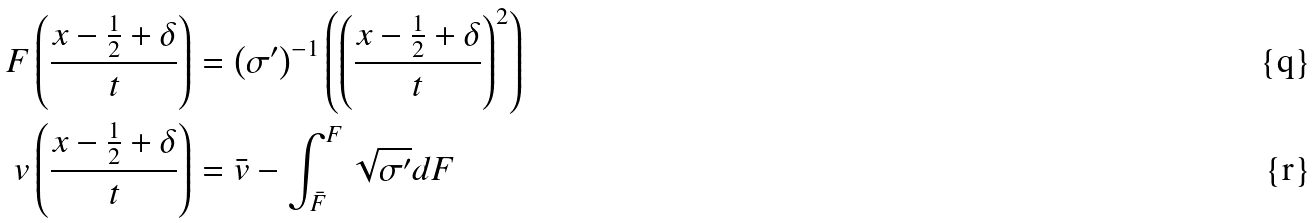<formula> <loc_0><loc_0><loc_500><loc_500>F \left ( \frac { x - \frac { 1 } { 2 } + \delta } { t } \right ) & = \left ( \sigma ^ { \prime } \right ) ^ { - 1 } \left ( \left ( \frac { x - \frac { 1 } { 2 } + \delta } { t } \right ) ^ { 2 } \right ) \\ v \left ( \frac { x - \frac { 1 } { 2 } + \delta } { t } \right ) & = \bar { v } - \int _ { \bar { F } } ^ { F } \sqrt { \sigma ^ { \prime } } d F</formula> 